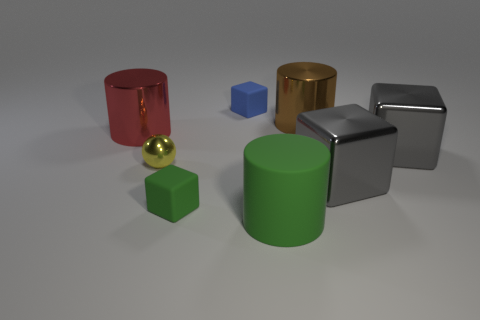Subtract all metal cylinders. How many cylinders are left? 1 Add 1 tiny yellow metallic spheres. How many objects exist? 9 Subtract all green cubes. How many cubes are left? 3 Subtract 1 cubes. How many cubes are left? 3 Subtract all purple blocks. Subtract all blue spheres. How many blocks are left? 4 Subtract all cylinders. How many objects are left? 5 Subtract all large brown things. Subtract all tiny yellow metal spheres. How many objects are left? 6 Add 4 big metal things. How many big metal things are left? 8 Add 6 matte cubes. How many matte cubes exist? 8 Subtract 1 yellow spheres. How many objects are left? 7 